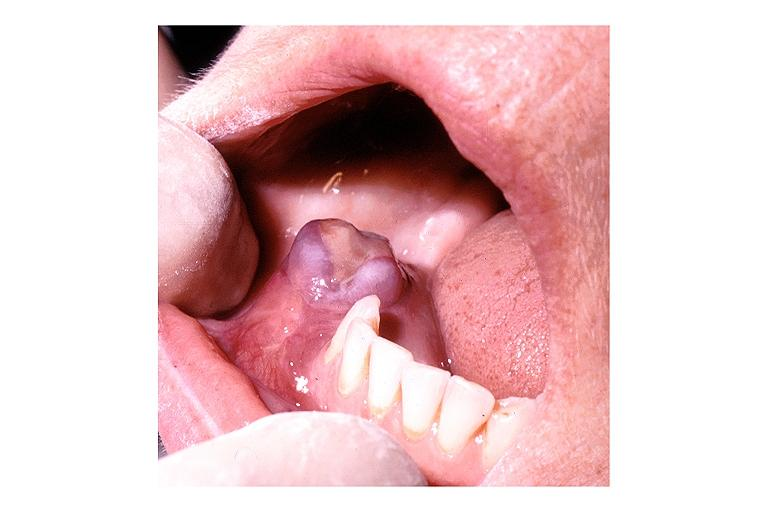does this image show hyperparathyroidism brown tumor?
Answer the question using a single word or phrase. Yes 